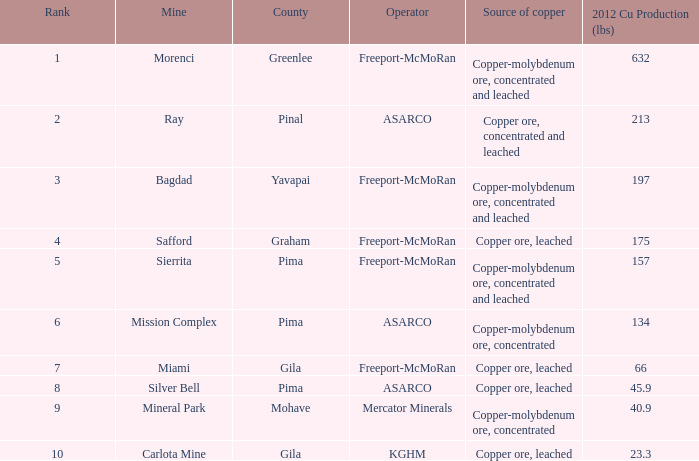What's the name of the operator who has the mission complex mine and has a 2012 Cu Production (lbs) larger than 23.3? ASARCO. 